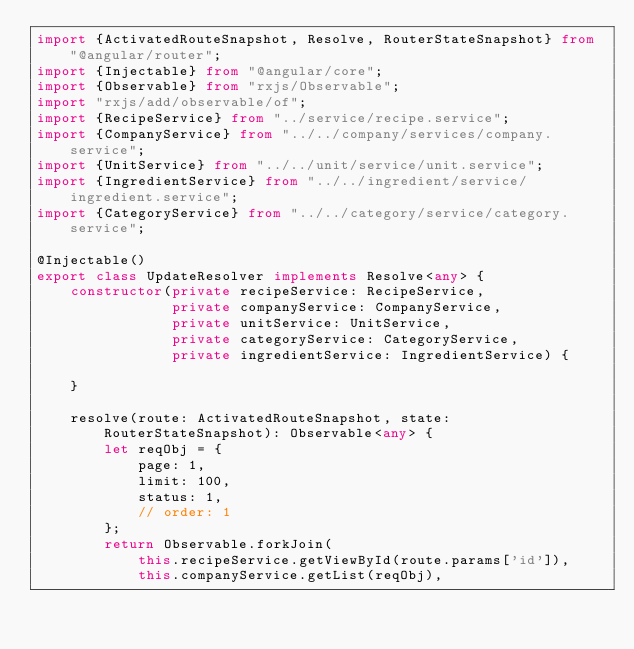Convert code to text. <code><loc_0><loc_0><loc_500><loc_500><_TypeScript_>import {ActivatedRouteSnapshot, Resolve, RouterStateSnapshot} from "@angular/router";
import {Injectable} from "@angular/core";
import {Observable} from "rxjs/Observable";
import "rxjs/add/observable/of";
import {RecipeService} from "../service/recipe.service";
import {CompanyService} from "../../company/services/company.service";
import {UnitService} from "../../unit/service/unit.service";
import {IngredientService} from "../../ingredient/service/ingredient.service";
import {CategoryService} from "../../category/service/category.service";

@Injectable()
export class UpdateResolver implements Resolve<any> {
    constructor(private recipeService: RecipeService,
                private companyService: CompanyService,
                private unitService: UnitService,
                private categoryService: CategoryService,
                private ingredientService: IngredientService) {

    }

    resolve(route: ActivatedRouteSnapshot, state: RouterStateSnapshot): Observable<any> {
        let reqObj = {
            page: 1,
            limit: 100,
            status: 1,
            // order: 1
        };
        return Observable.forkJoin(
            this.recipeService.getViewById(route.params['id']),
            this.companyService.getList(reqObj),</code> 